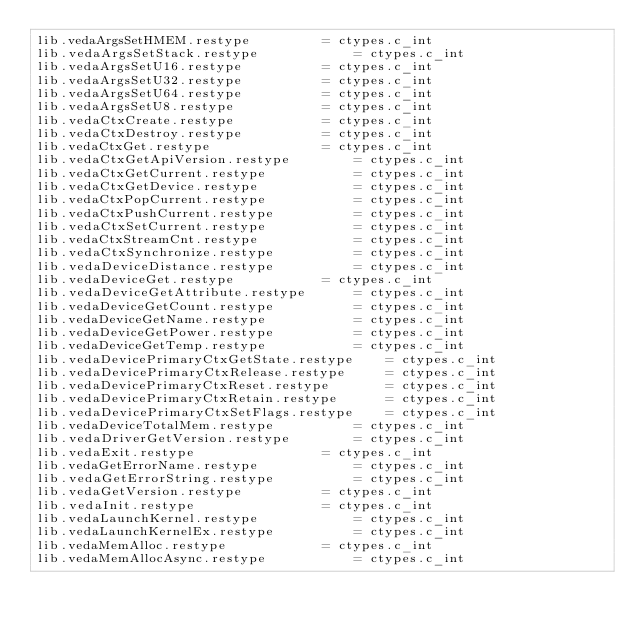<code> <loc_0><loc_0><loc_500><loc_500><_Python_>lib.vedaArgsSetHMEM.restype			= ctypes.c_int
lib.vedaArgsSetStack.restype			= ctypes.c_int
lib.vedaArgsSetU16.restype			= ctypes.c_int
lib.vedaArgsSetU32.restype			= ctypes.c_int
lib.vedaArgsSetU64.restype			= ctypes.c_int
lib.vedaArgsSetU8.restype			= ctypes.c_int
lib.vedaCtxCreate.restype			= ctypes.c_int
lib.vedaCtxDestroy.restype			= ctypes.c_int
lib.vedaCtxGet.restype				= ctypes.c_int
lib.vedaCtxGetApiVersion.restype		= ctypes.c_int
lib.vedaCtxGetCurrent.restype			= ctypes.c_int
lib.vedaCtxGetDevice.restype			= ctypes.c_int
lib.vedaCtxPopCurrent.restype			= ctypes.c_int
lib.vedaCtxPushCurrent.restype			= ctypes.c_int
lib.vedaCtxSetCurrent.restype			= ctypes.c_int
lib.vedaCtxStreamCnt.restype			= ctypes.c_int
lib.vedaCtxSynchronize.restype			= ctypes.c_int
lib.vedaDeviceDistance.restype			= ctypes.c_int
lib.vedaDeviceGet.restype			= ctypes.c_int
lib.vedaDeviceGetAttribute.restype		= ctypes.c_int
lib.vedaDeviceGetCount.restype			= ctypes.c_int
lib.vedaDeviceGetName.restype			= ctypes.c_int
lib.vedaDeviceGetPower.restype			= ctypes.c_int
lib.vedaDeviceGetTemp.restype			= ctypes.c_int
lib.vedaDevicePrimaryCtxGetState.restype	= ctypes.c_int
lib.vedaDevicePrimaryCtxRelease.restype		= ctypes.c_int
lib.vedaDevicePrimaryCtxReset.restype		= ctypes.c_int
lib.vedaDevicePrimaryCtxRetain.restype		= ctypes.c_int
lib.vedaDevicePrimaryCtxSetFlags.restype	= ctypes.c_int
lib.vedaDeviceTotalMem.restype			= ctypes.c_int
lib.vedaDriverGetVersion.restype		= ctypes.c_int
lib.vedaExit.restype				= ctypes.c_int
lib.vedaGetErrorName.restype			= ctypes.c_int
lib.vedaGetErrorString.restype			= ctypes.c_int
lib.vedaGetVersion.restype			= ctypes.c_int
lib.vedaInit.restype				= ctypes.c_int
lib.vedaLaunchKernel.restype			= ctypes.c_int
lib.vedaLaunchKernelEx.restype			= ctypes.c_int
lib.vedaMemAlloc.restype			= ctypes.c_int
lib.vedaMemAllocAsync.restype			= ctypes.c_int</code> 